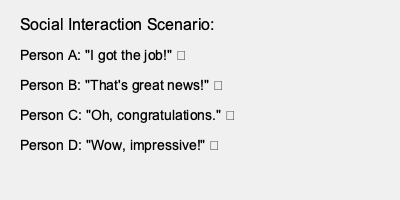As a behavioral psychologist, analyze the emojis used in the social interaction scenario. Which person's response might indicate potential underlying issues in their relationship with Person A? To analyze this social interaction scenario, we need to interpret the facial expressions represented by the emojis and their potential implications for interpersonal relationships:

1. Person A (😃): Expresses genuine happiness and excitement about getting the job.

2. Person B (😊): Shows a positive, supportive response with a warm smile, indicating a good relationship with Person A.

3. Person C (😐): Uses a neutral face, which might suggest a lack of enthusiasm or emotional investment in Person A's success. This could indicate a strained or distant relationship.

4. Person D (🙄): Employs an eye-rolling emoji, which typically conveys skepticism, disbelief, or annoyance. This response is the most concerning, as it suggests potential negative feelings towards Person A's success.

Among these responses, Person D's use of the eye-rolling emoji (🙄) is the most indicative of potential underlying issues in their relationship with Person A. The mismatch between the congratulatory words and the skeptical or annoyed facial expression suggests possible feelings of jealousy, resentment, or insincerity.

From a behavioral psychology perspective, this incongruence between verbal and non-verbal communication (represented by the emoji) could signify unresolved conflicts, competitive feelings, or other relational issues that may require further exploration to maintain healthy social dynamics.
Answer: Person D 